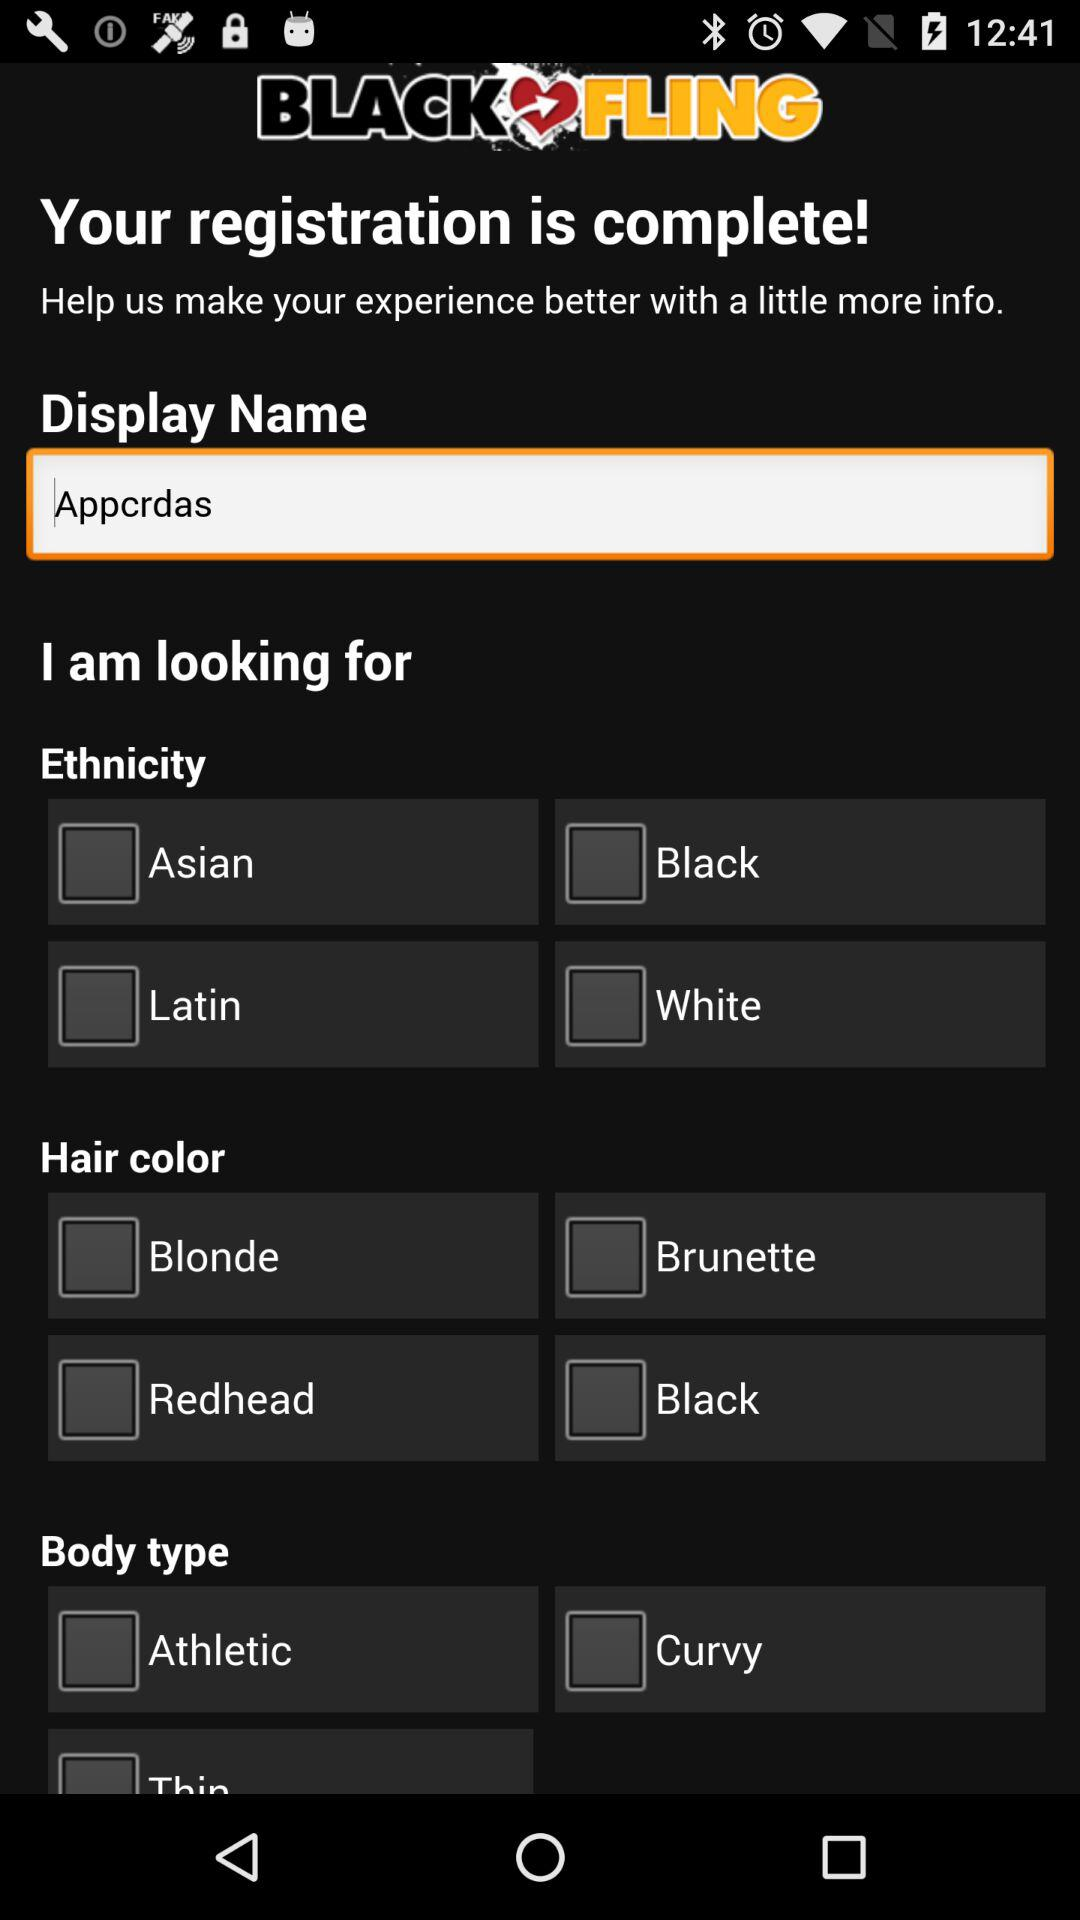How many ethnicity options are there?
Answer the question using a single word or phrase. 4 